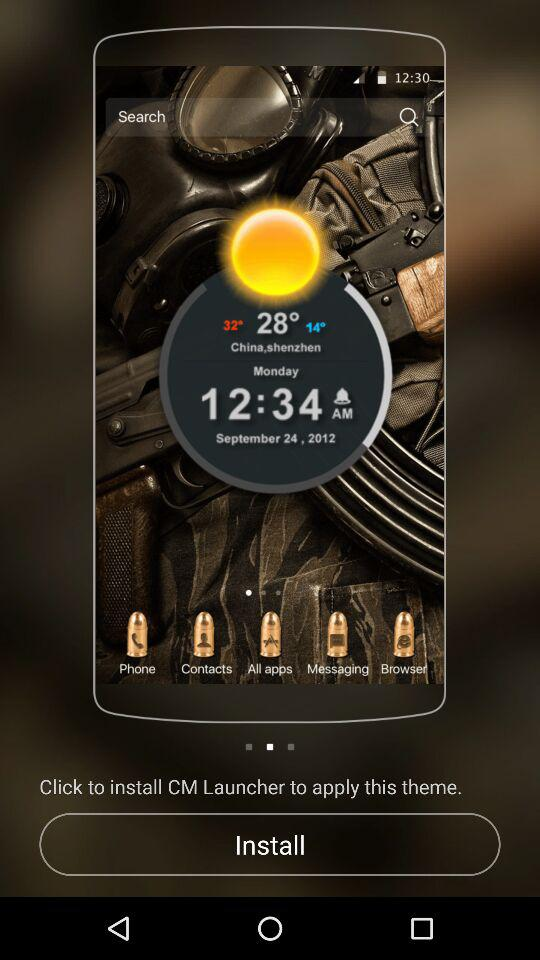What is the date? The date is Monday, September 24, 2012. 